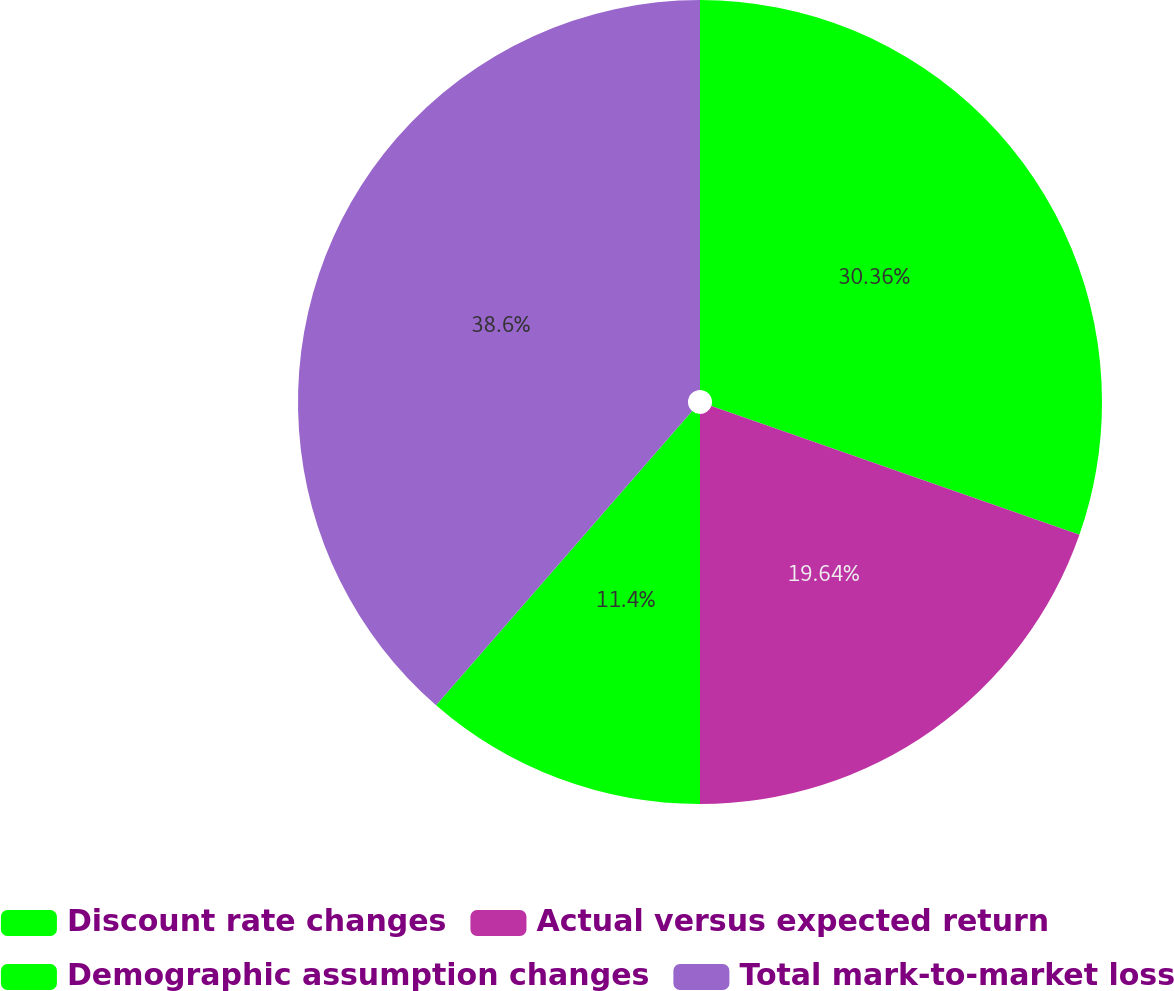Convert chart to OTSL. <chart><loc_0><loc_0><loc_500><loc_500><pie_chart><fcel>Discount rate changes<fcel>Actual versus expected return<fcel>Demographic assumption changes<fcel>Total mark-to-market loss<nl><fcel>30.36%<fcel>19.64%<fcel>11.4%<fcel>38.6%<nl></chart> 